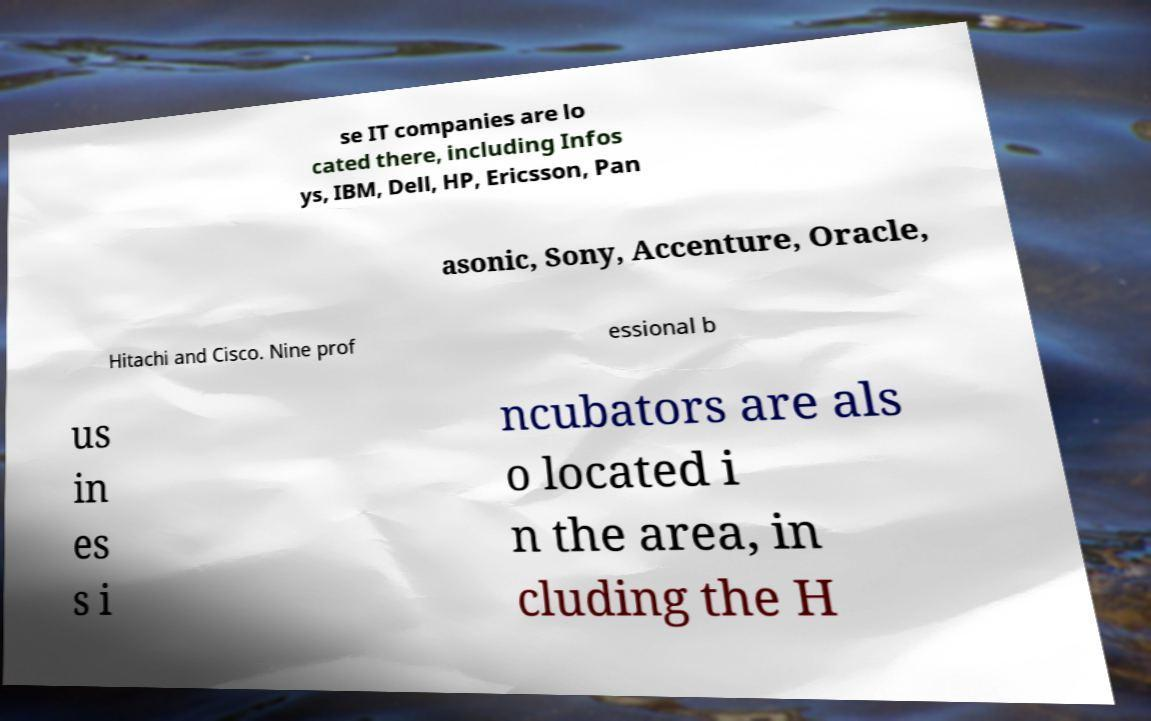Could you assist in decoding the text presented in this image and type it out clearly? se IT companies are lo cated there, including Infos ys, IBM, Dell, HP, Ericsson, Pan asonic, Sony, Accenture, Oracle, Hitachi and Cisco. Nine prof essional b us in es s i ncubators are als o located i n the area, in cluding the H 